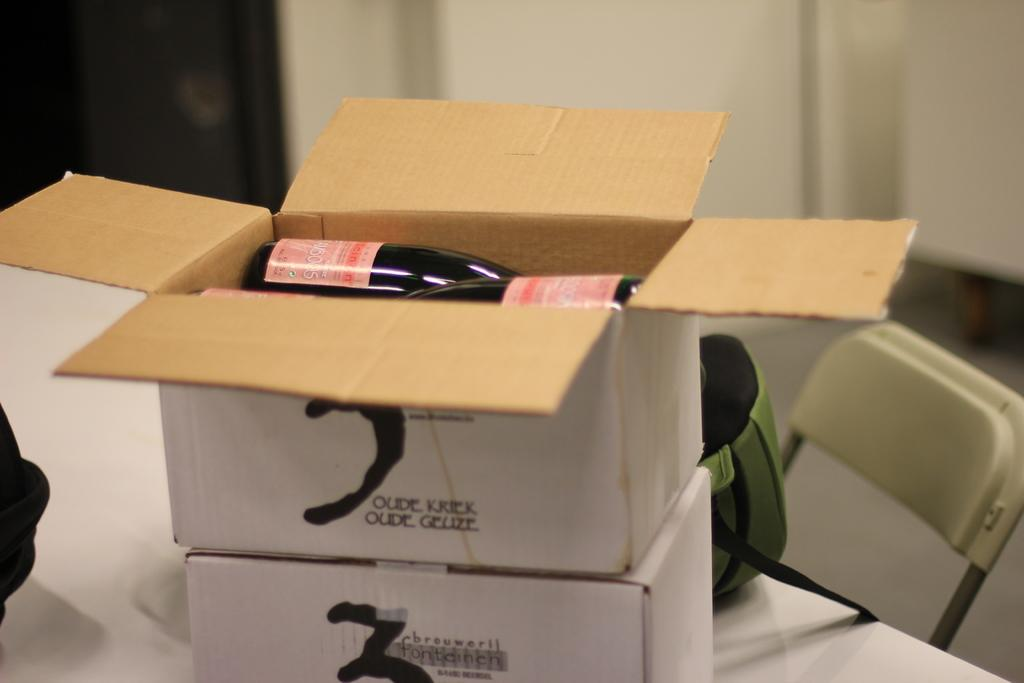<image>
Offer a succinct explanation of the picture presented. Boxes of Brouwerij Fonteinen Oude Kriek rest on a tabletop. 